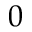<formula> <loc_0><loc_0><loc_500><loc_500>0</formula> 